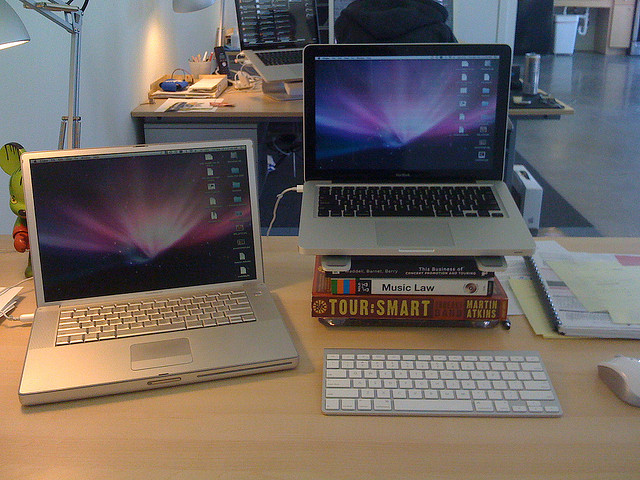<image>What letter is in the upper right corner of the left computer? It is unknown what letter is in the upper right corner of the left computer as it appears to be unclear. What letter is in the upper right corner of the left computer? I don't know what letter is in the upper right corner of the left computer. It is unclear or there may be no letter at all. 